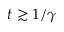<formula> <loc_0><loc_0><loc_500><loc_500>t \gtrsim 1 / \gamma</formula> 